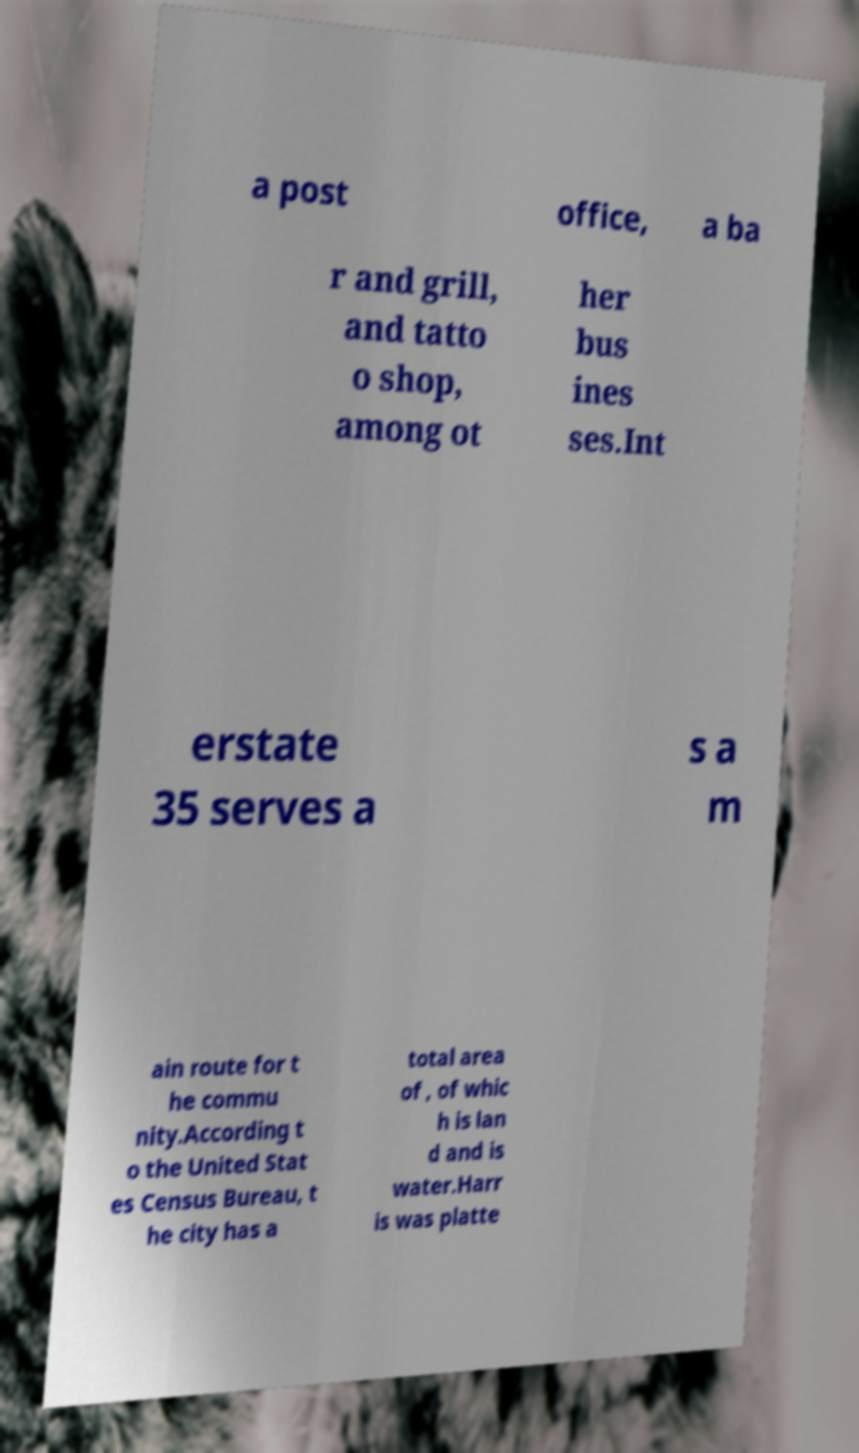Please read and relay the text visible in this image. What does it say? a post office, a ba r and grill, and tatto o shop, among ot her bus ines ses.Int erstate 35 serves a s a m ain route for t he commu nity.According t o the United Stat es Census Bureau, t he city has a total area of , of whic h is lan d and is water.Harr is was platte 